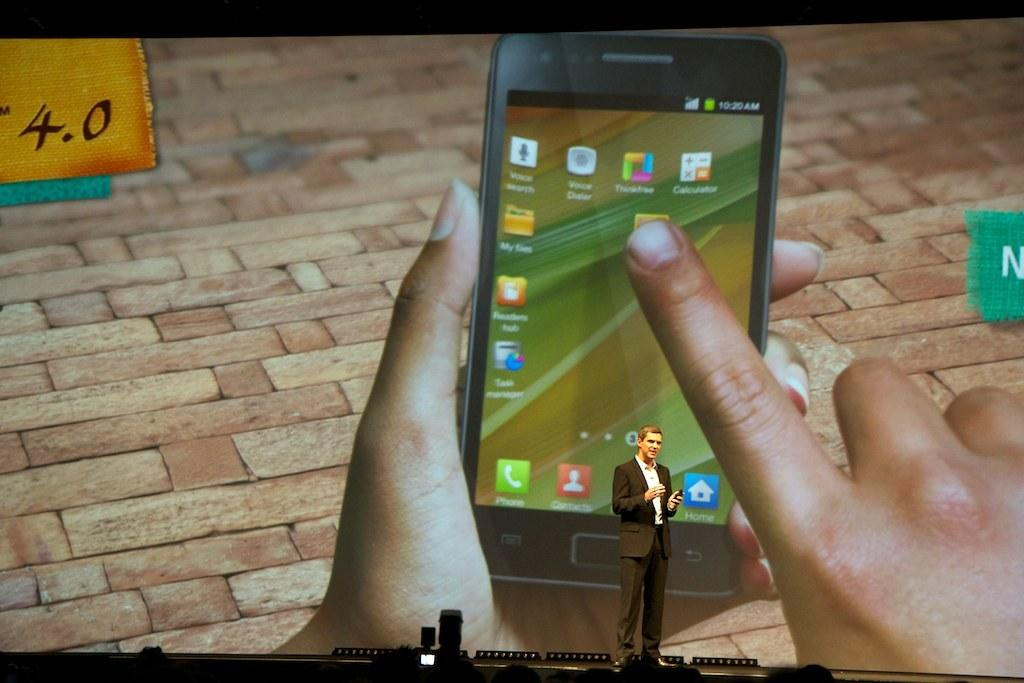Provide a one-sentence caption for the provided image. A man is giving a presentation with a screen showing someone holding phone with the time of 10:20 AM. 